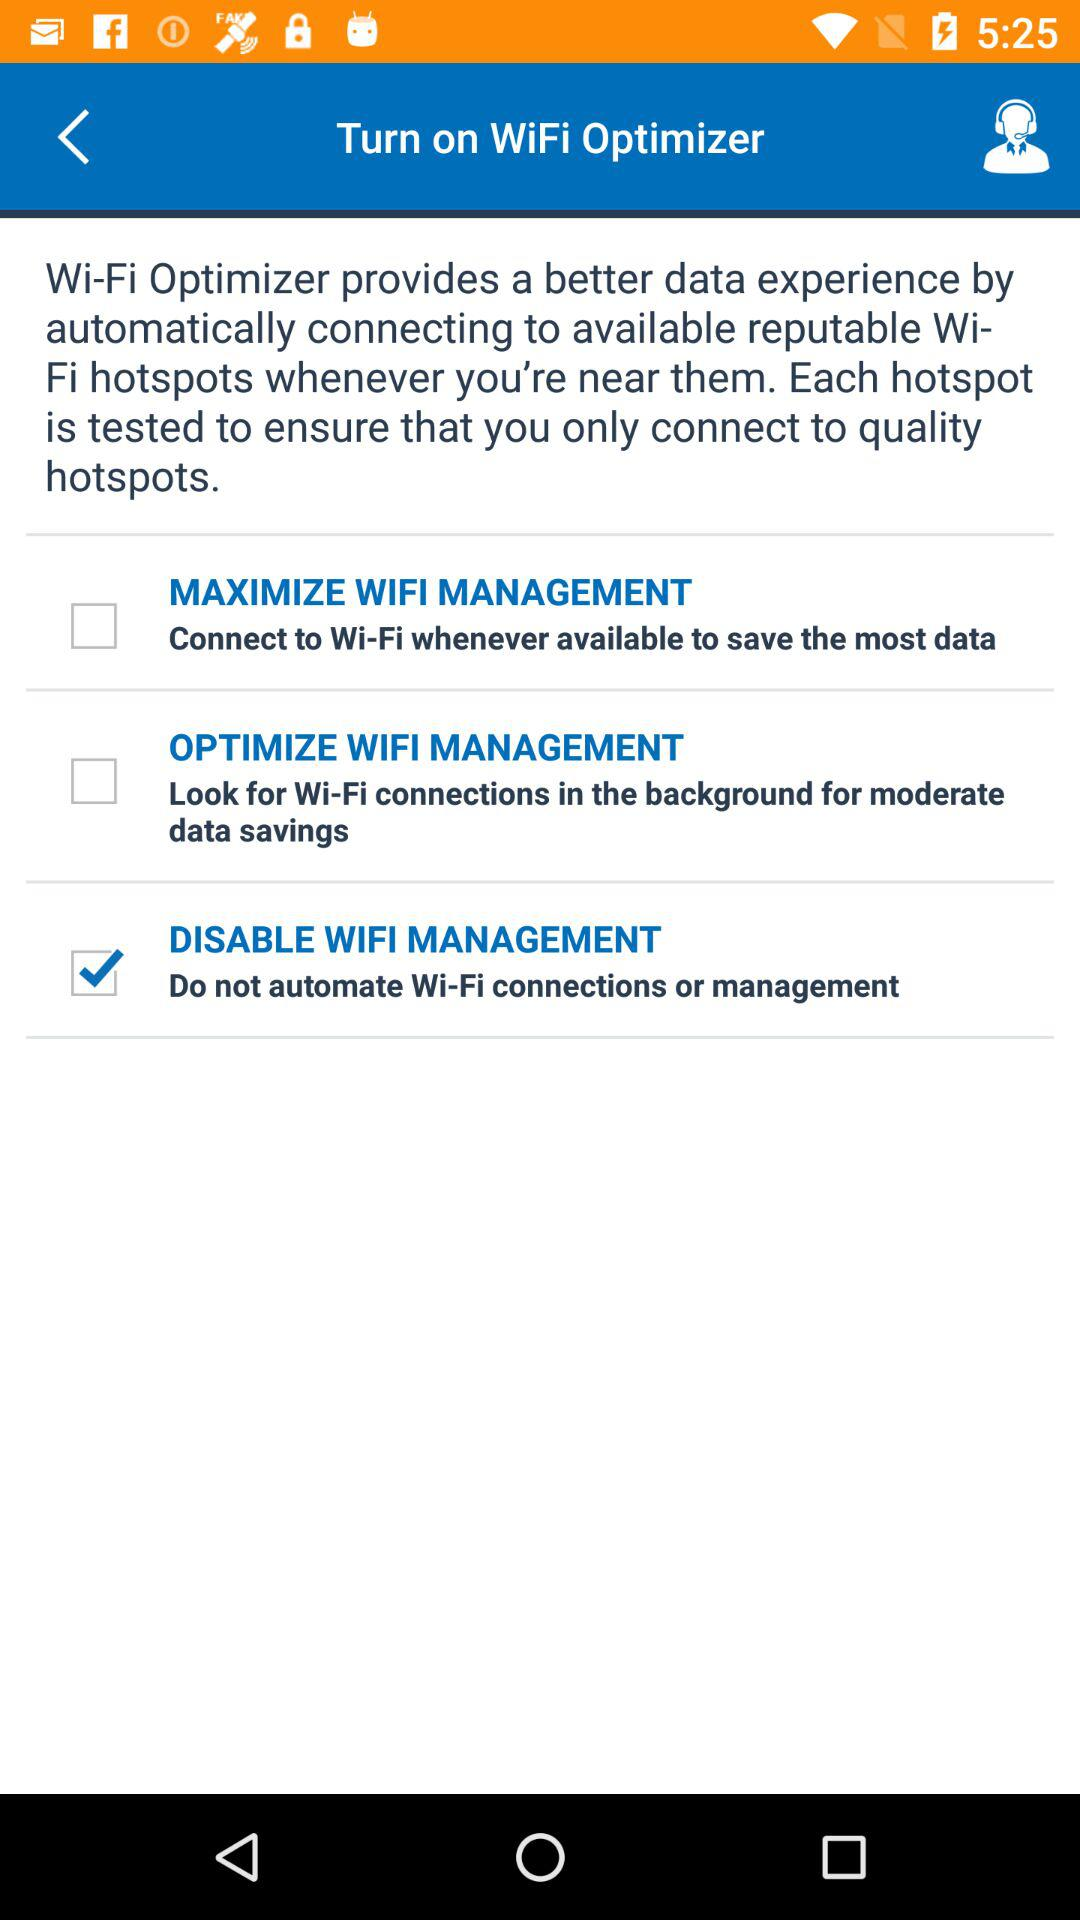How many Wi-Fi Optimizer options are there?
Answer the question using a single word or phrase. 3 